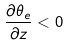<formula> <loc_0><loc_0><loc_500><loc_500>\frac { \partial \theta _ { e } } { \partial z } < 0</formula> 